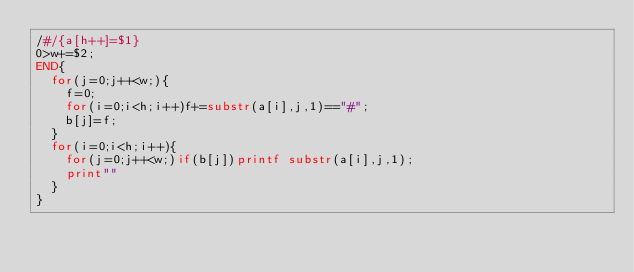<code> <loc_0><loc_0><loc_500><loc_500><_Awk_>/#/{a[h++]=$1}
0>w+=$2;
END{
	for(j=0;j++<w;){
		f=0;
		for(i=0;i<h;i++)f+=substr(a[i],j,1)=="#";
		b[j]=f;
	}
	for(i=0;i<h;i++){
		for(j=0;j++<w;)if(b[j])printf substr(a[i],j,1);
		print""
	}
}
</code> 